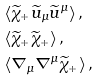<formula> <loc_0><loc_0><loc_500><loc_500>& \langle \widetilde { \chi } _ { + } \widetilde { u } _ { \mu } \widetilde { u } ^ { \mu } \rangle \, , \\ & \langle \widetilde { \chi } _ { + } \widetilde { \chi } _ { + } \rangle \, , \\ & \langle \nabla _ { \mu } \nabla ^ { \mu } \widetilde { \chi } _ { + } \rangle \, ,</formula> 